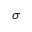Convert formula to latex. <formula><loc_0><loc_0><loc_500><loc_500>\sigma</formula> 